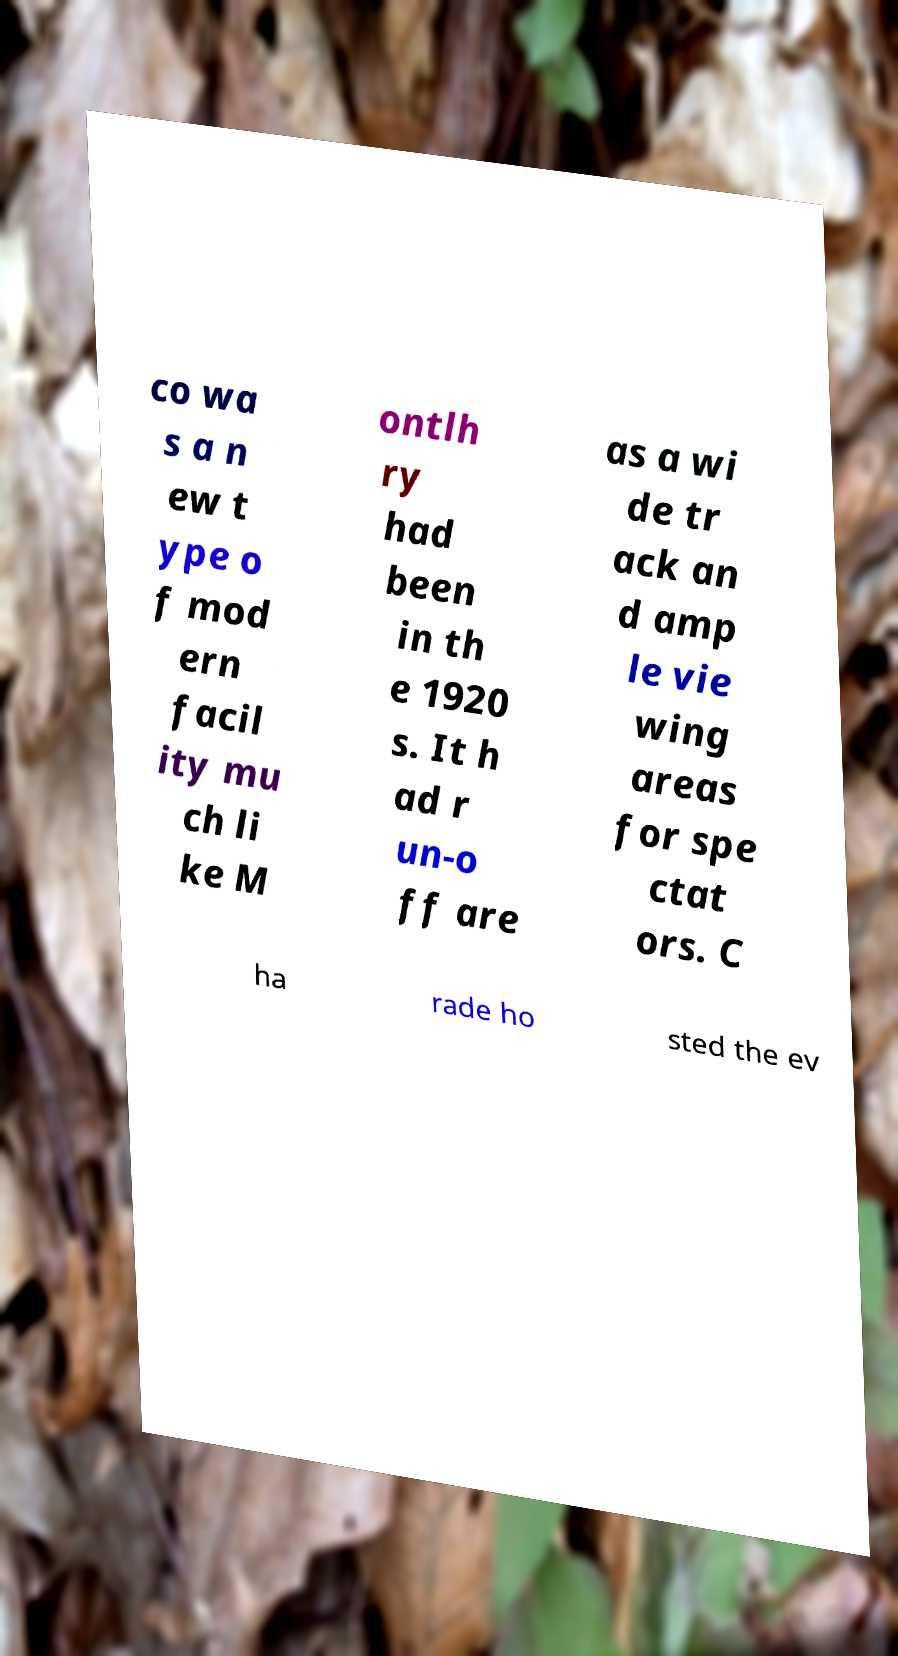Could you extract and type out the text from this image? co wa s a n ew t ype o f mod ern facil ity mu ch li ke M ontlh ry had been in th e 1920 s. It h ad r un-o ff are as a wi de tr ack an d amp le vie wing areas for spe ctat ors. C ha rade ho sted the ev 